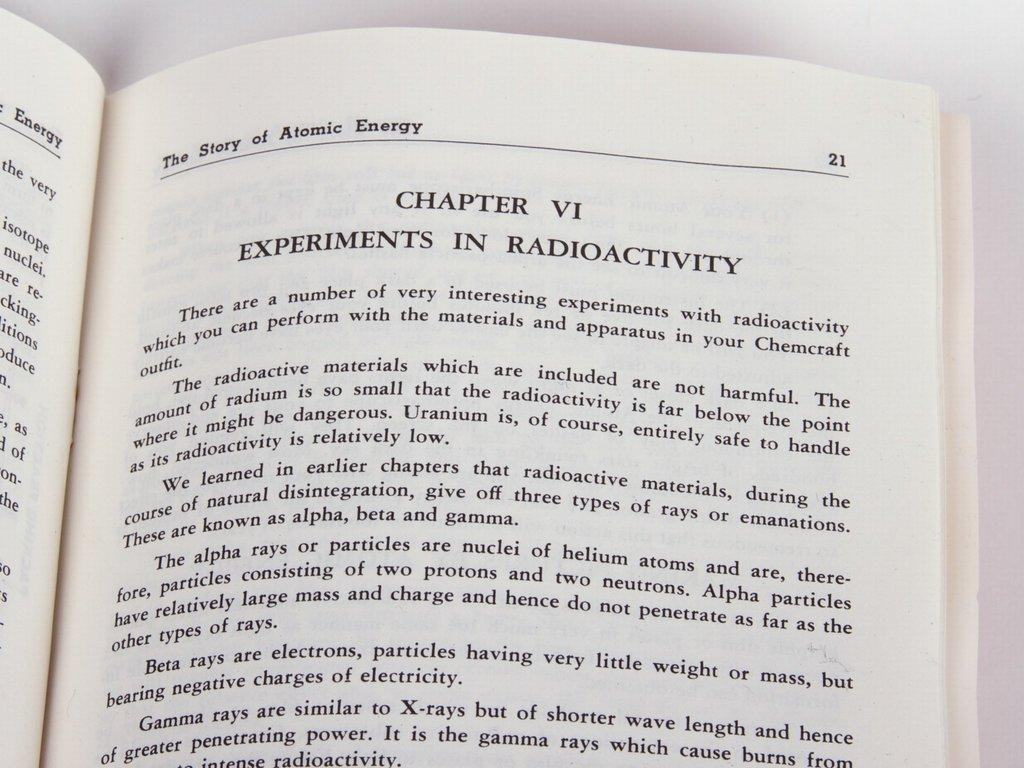Provide a one-sentence caption for the provided image. The Story of Atomic Energy is opened to Chapter 6. 